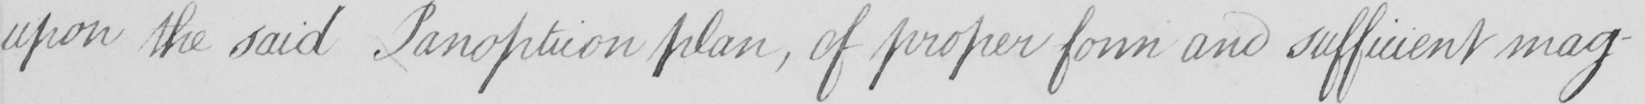What text is written in this handwritten line? upon the said Panopticon plan , of proper form and sufficient mag- 